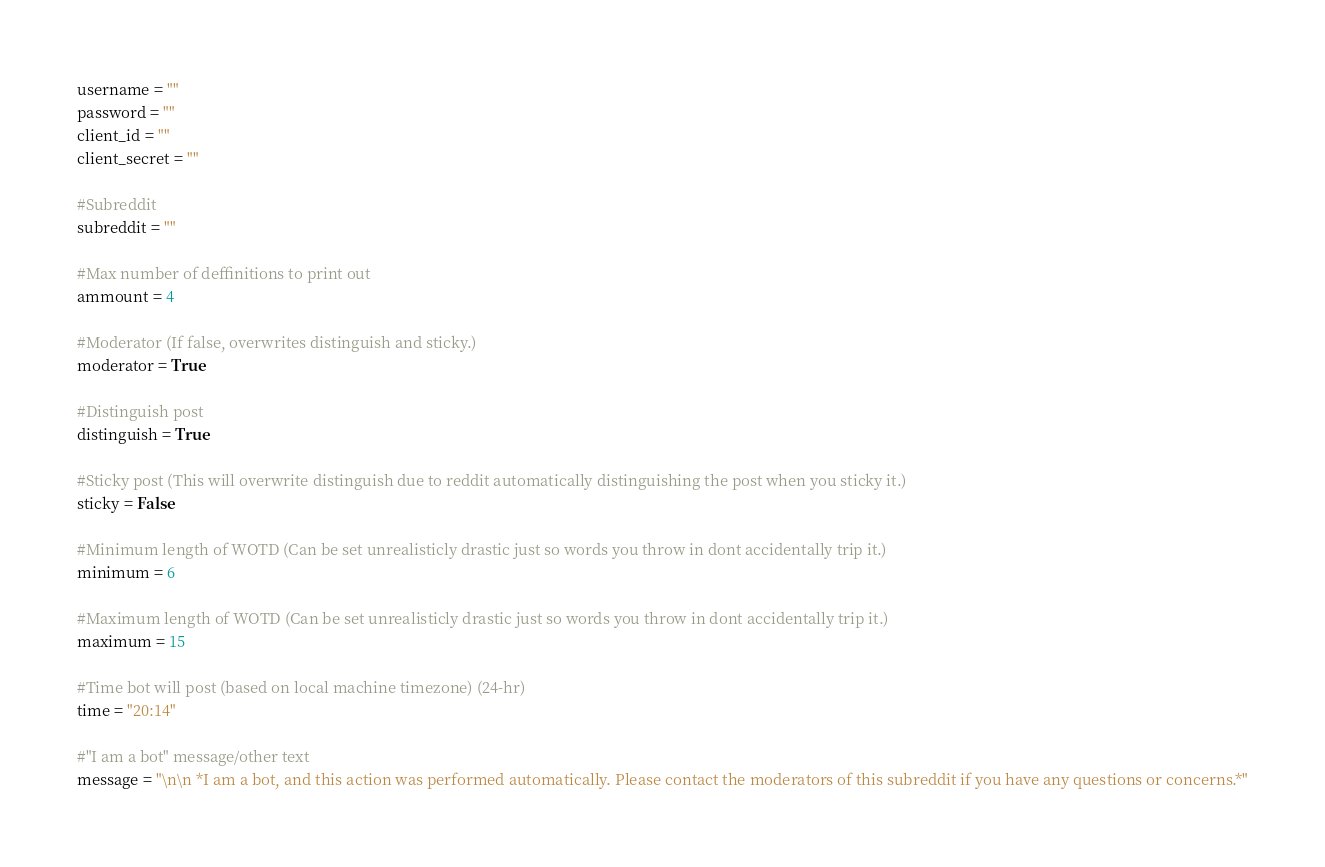Convert code to text. <code><loc_0><loc_0><loc_500><loc_500><_Python_>username = ""
password = ""
client_id = ""
client_secret = ""

#Subreddit
subreddit = ""

#Max number of deffinitions to print out
ammount = 4

#Moderator (If false, overwrites distinguish and sticky.)
moderator = True

#Distinguish post
distinguish = True

#Sticky post (This will overwrite distinguish due to reddit automatically distinguishing the post when you sticky it.)
sticky = False

#Minimum length of WOTD (Can be set unrealisticly drastic just so words you throw in dont accidentally trip it.)
minimum = 6

#Maximum length of WOTD (Can be set unrealisticly drastic just so words you throw in dont accidentally trip it.)
maximum = 15

#Time bot will post (based on local machine timezone) (24-hr)
time = "20:14"

#"I am a bot" message/other text
message = "\n\n *I am a bot, and this action was performed automatically. Please contact the moderators of this subreddit if you have any questions or concerns.*"</code> 